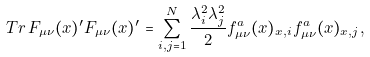Convert formula to latex. <formula><loc_0><loc_0><loc_500><loc_500>T r \, F _ { \mu \nu } ( x ) ^ { \prime } F _ { \mu \nu } ( x ) ^ { \prime } = \sum _ { i , j = 1 } ^ { N } \frac { \lambda _ { i } ^ { 2 } \lambda _ { j } ^ { 2 } } { 2 } f ^ { a } _ { \mu \nu } ( x ) _ { x , i } f ^ { a } _ { \mu \nu } ( x ) _ { x , j } ,</formula> 